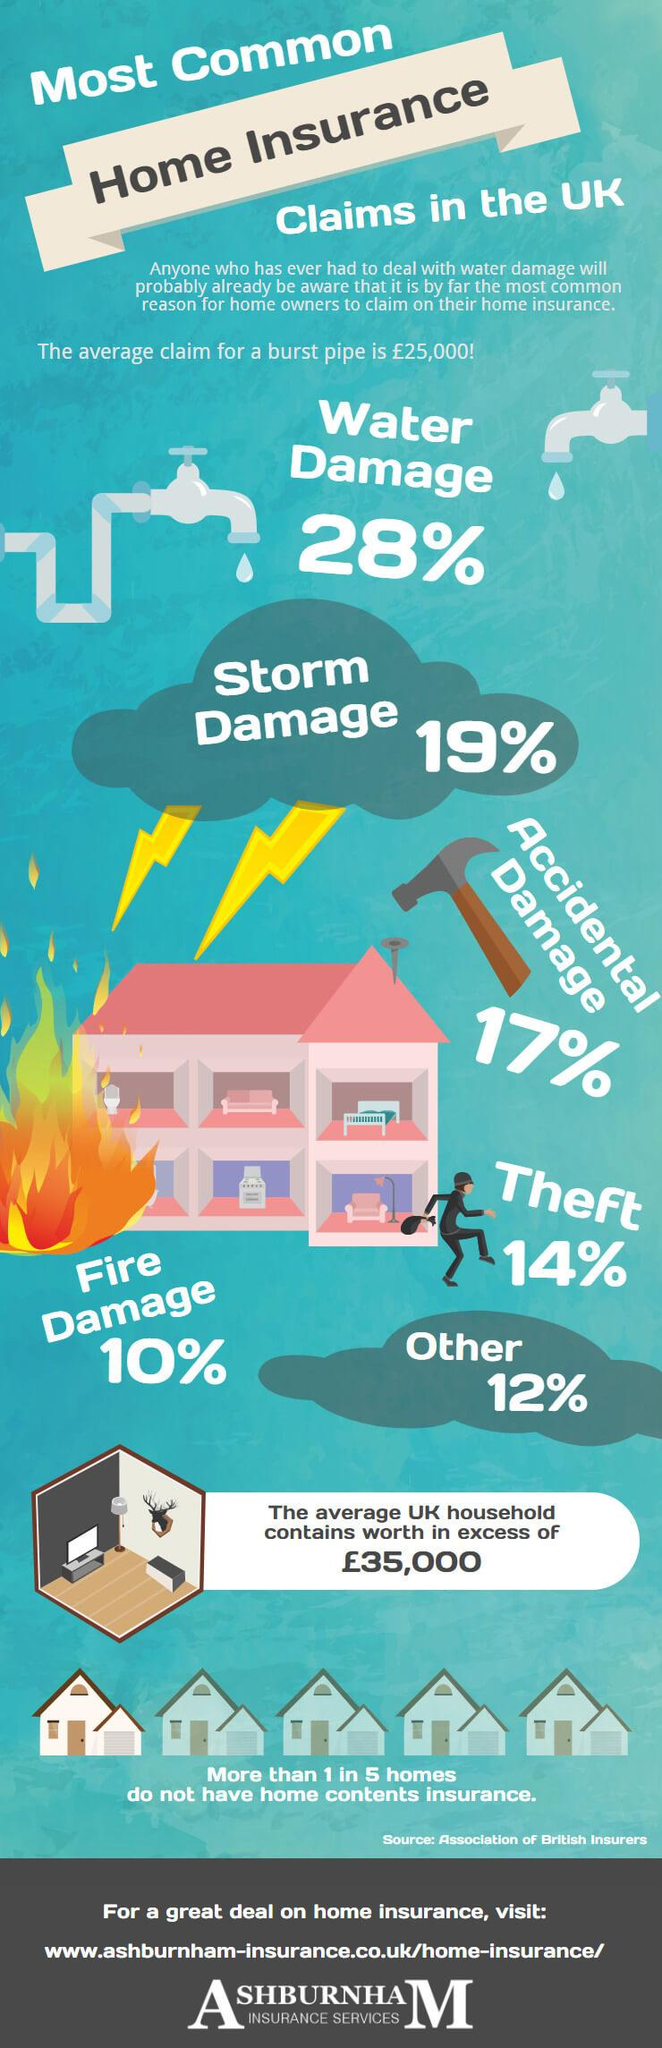Identify some key points in this picture. Homeowners may be able to claim a maximum of 24% of the value of their property for fire damage and theft. 